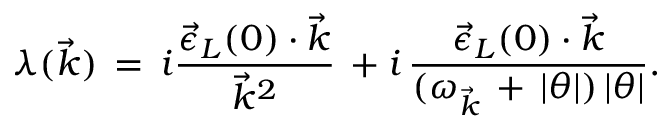Convert formula to latex. <formula><loc_0><loc_0><loc_500><loc_500>\lambda ( \vec { k } ) \, = \, i \frac { { \vec { \epsilon } } _ { L } ( 0 ) \cdot \vec { k } } { { \vec { k } } ^ { 2 } } \, + i \, \frac { { \vec { \epsilon } } _ { L } ( 0 ) \cdot \vec { k } } { ( \omega _ { \vec { k } } \, + \, | \theta | ) \, | \theta | } .</formula> 